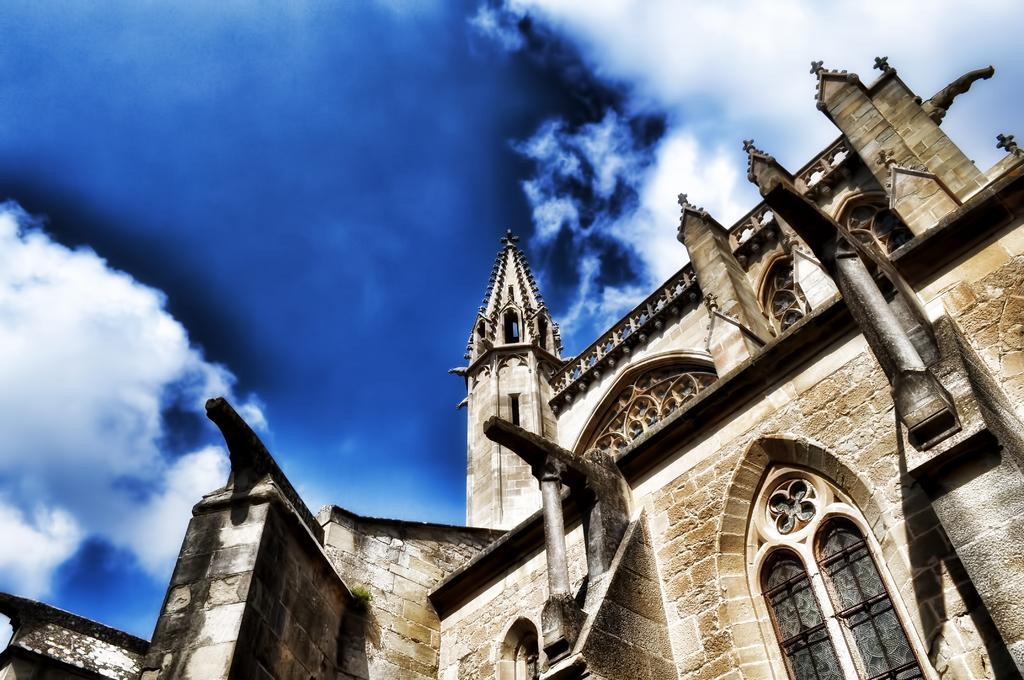What is the main structure visible in the foreground of the image? There is a building in the foreground area of the image. What part of the natural environment can be seen in the image? The sky is visible in the background of the image. What type of brush is being used by the person in the image? There is no person or brush present in the image; it only features a building and the sky. 